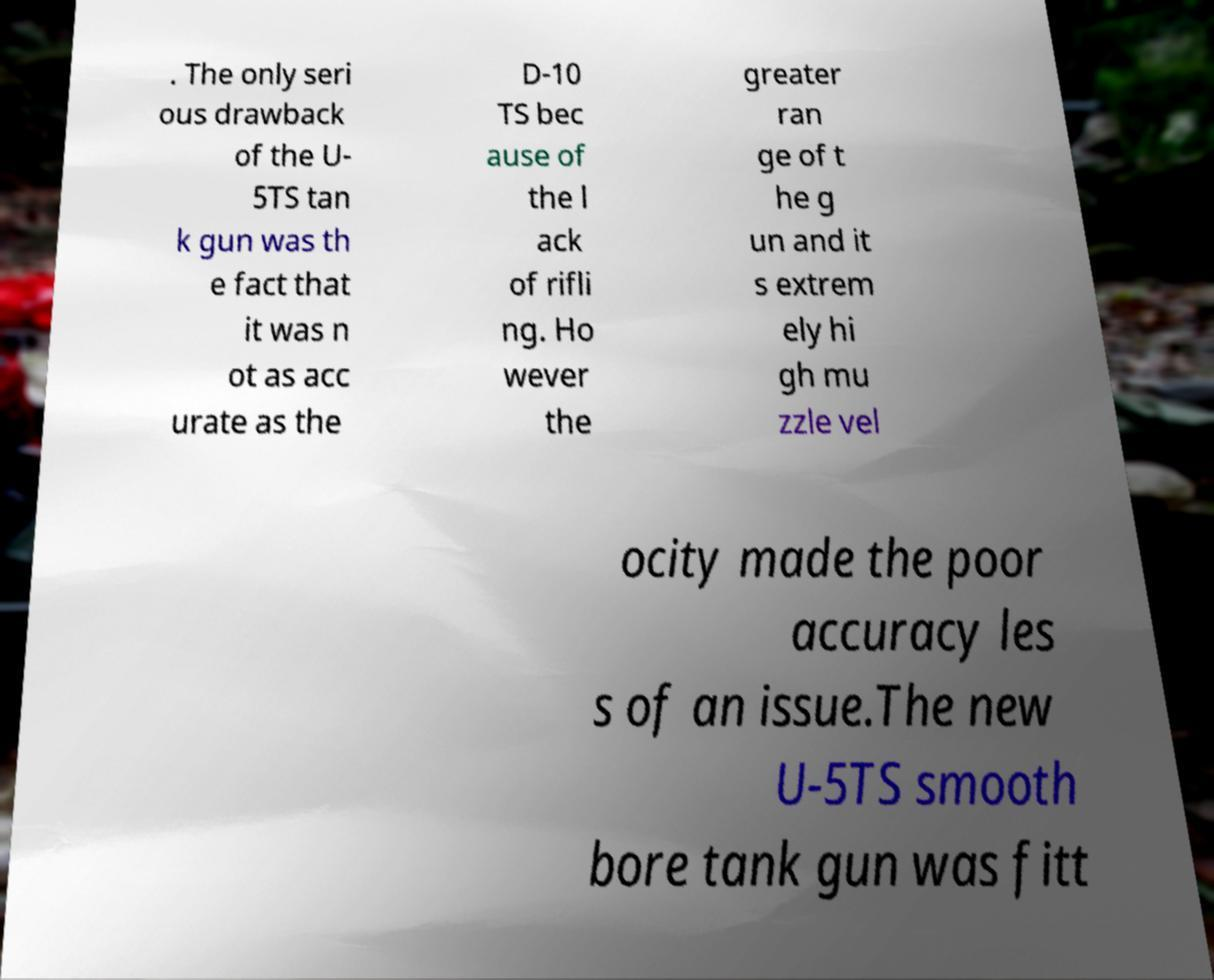Could you extract and type out the text from this image? . The only seri ous drawback of the U- 5TS tan k gun was th e fact that it was n ot as acc urate as the D-10 TS bec ause of the l ack of rifli ng. Ho wever the greater ran ge of t he g un and it s extrem ely hi gh mu zzle vel ocity made the poor accuracy les s of an issue.The new U-5TS smooth bore tank gun was fitt 